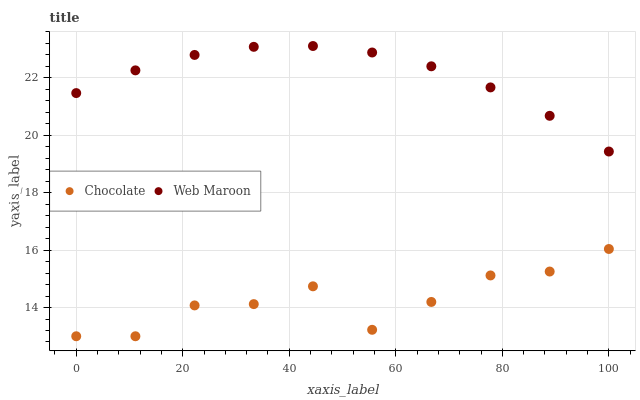Does Chocolate have the minimum area under the curve?
Answer yes or no. Yes. Does Web Maroon have the maximum area under the curve?
Answer yes or no. Yes. Does Chocolate have the maximum area under the curve?
Answer yes or no. No. Is Web Maroon the smoothest?
Answer yes or no. Yes. Is Chocolate the roughest?
Answer yes or no. Yes. Is Chocolate the smoothest?
Answer yes or no. No. Does Chocolate have the lowest value?
Answer yes or no. Yes. Does Web Maroon have the highest value?
Answer yes or no. Yes. Does Chocolate have the highest value?
Answer yes or no. No. Is Chocolate less than Web Maroon?
Answer yes or no. Yes. Is Web Maroon greater than Chocolate?
Answer yes or no. Yes. Does Chocolate intersect Web Maroon?
Answer yes or no. No. 